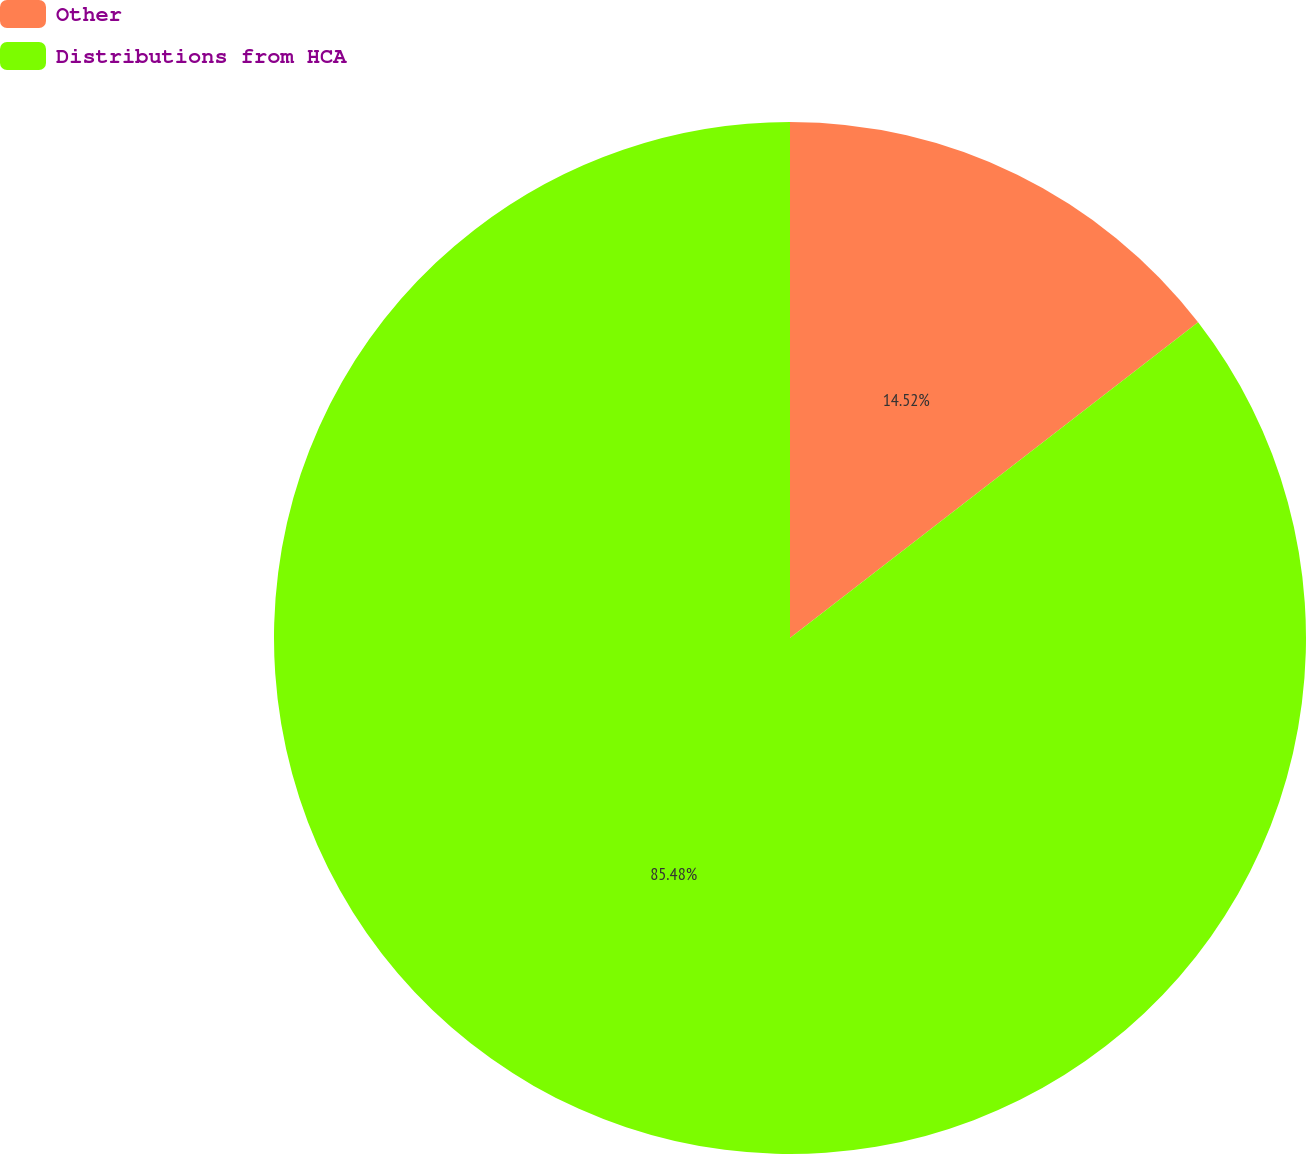Convert chart to OTSL. <chart><loc_0><loc_0><loc_500><loc_500><pie_chart><fcel>Other<fcel>Distributions from HCA<nl><fcel>14.52%<fcel>85.48%<nl></chart> 